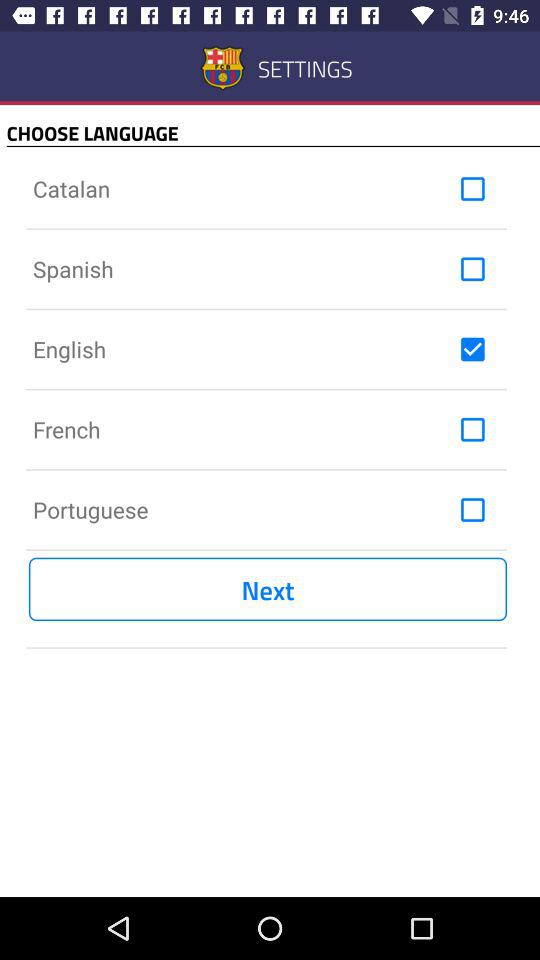How many languages are available to choose from?
Answer the question using a single word or phrase. 5 